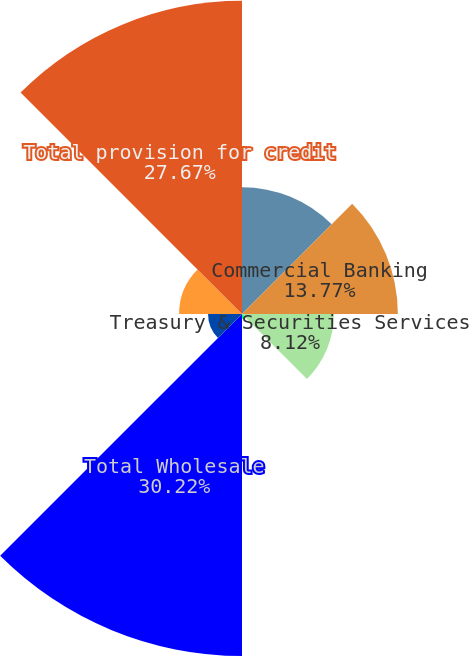<chart> <loc_0><loc_0><loc_500><loc_500><pie_chart><fcel>Investment Bank<fcel>Commercial Banking<fcel>Treasury & Securities Services<fcel>Asset Management<fcel>Total Wholesale<fcel>Retail Financial Services<fcel>Total Consumer<fcel>Total provision for credit<nl><fcel>11.21%<fcel>13.77%<fcel>8.12%<fcel>0.45%<fcel>30.22%<fcel>3.0%<fcel>5.56%<fcel>27.67%<nl></chart> 